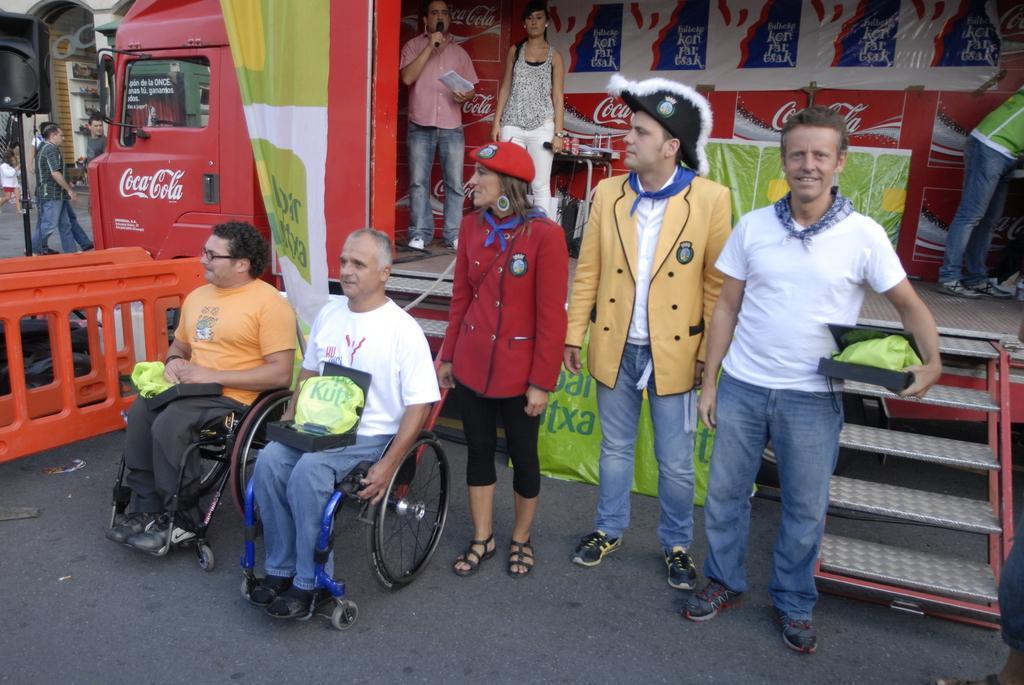Can you describe this image briefly? There are two persons sitting on wheel chairs and keeping boxes on their laps on the road, near a three persons who are standing. In the background, there are two persons on the stage, near a table, there is a person standing, there is a banner, hoarding, there are persons standing on the road, there is a vehicle, there are buildings and other objects. 